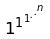Convert formula to latex. <formula><loc_0><loc_0><loc_500><loc_500>1 ^ { 1 ^ { 1 ^ { . ^ { . ^ { n } } } } }</formula> 